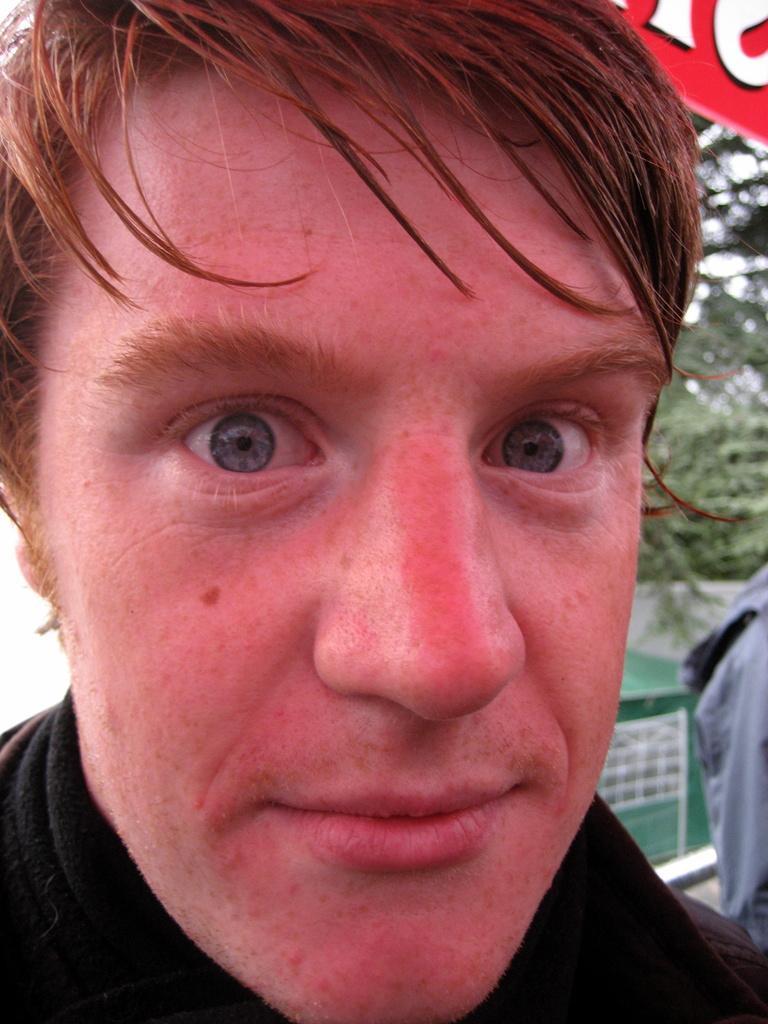Describe this image in one or two sentences. In this image we can see a person's face. In the background there is a person and trees. 